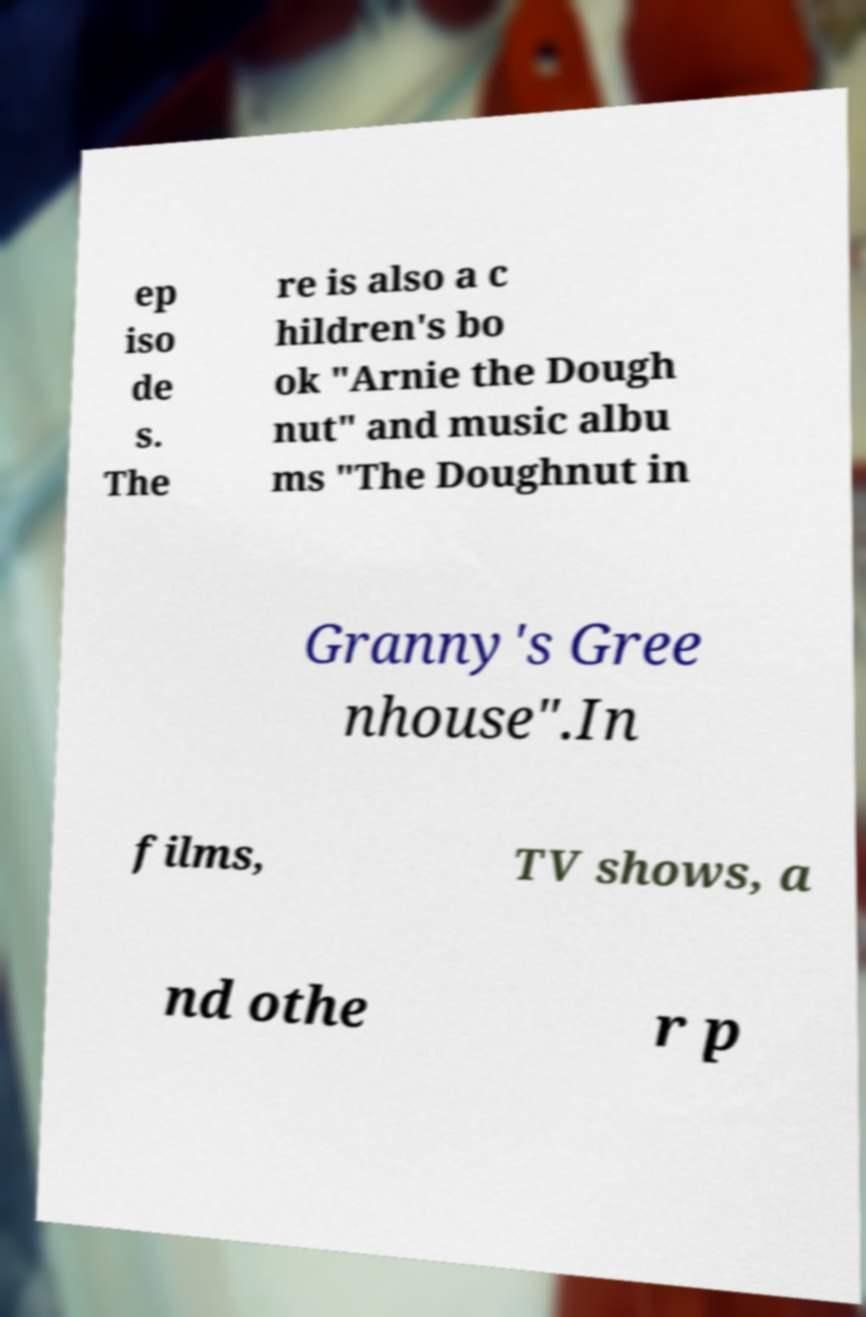There's text embedded in this image that I need extracted. Can you transcribe it verbatim? ep iso de s. The re is also a c hildren's bo ok "Arnie the Dough nut" and music albu ms "The Doughnut in Granny's Gree nhouse".In films, TV shows, a nd othe r p 